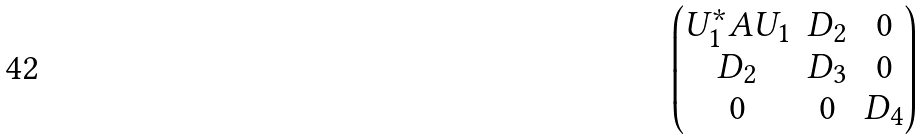Convert formula to latex. <formula><loc_0><loc_0><loc_500><loc_500>\begin{pmatrix} U _ { 1 } ^ { * } A U _ { 1 } & D _ { 2 } & 0 \\ D _ { 2 } & D _ { 3 } & 0 \\ 0 & 0 & D _ { 4 } \end{pmatrix}</formula> 